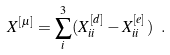<formula> <loc_0><loc_0><loc_500><loc_500>X ^ { [ \mu ] } = \sum _ { i } ^ { 3 } ( X ^ { [ d ] } _ { i i } - X ^ { [ e ] } _ { i i } ) \ .</formula> 